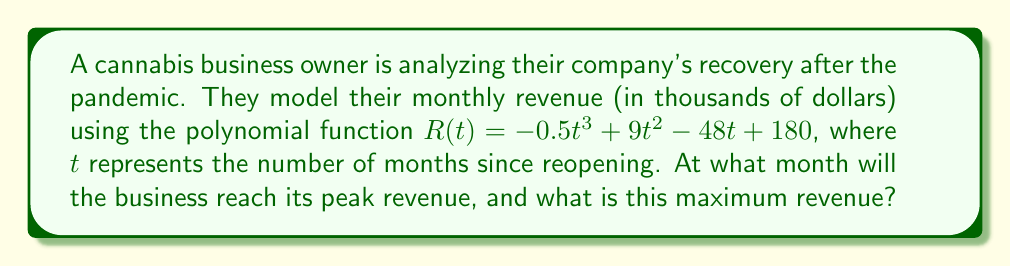Show me your answer to this math problem. To find the month of peak revenue and its value, we need to follow these steps:

1) The maximum point of the revenue function occurs where its derivative equals zero. Let's find the derivative of $R(t)$:

   $R'(t) = -1.5t^2 + 18t - 48$

2) Set $R'(t) = 0$ and solve for $t$:

   $-1.5t^2 + 18t - 48 = 0$

3) This is a quadratic equation. We can solve it using the quadratic formula:
   $t = \frac{-b \pm \sqrt{b^2 - 4ac}}{2a}$

   Where $a = -1.5$, $b = 18$, and $c = -48$

4) Substituting these values:

   $t = \frac{-18 \pm \sqrt{18^2 - 4(-1.5)(-48)}}{2(-1.5)}$

   $= \frac{-18 \pm \sqrt{324 - 288}}{-3}$

   $= \frac{-18 \pm \sqrt{36}}{-3}$

   $= \frac{-18 \pm 6}{-3}$

5) This gives us two solutions:
   $t = \frac{-18 + 6}{-3} = 4$ or $t = \frac{-18 - 6}{-3} = 8$

6) The second derivative $R''(t) = -3t + 18$ is negative when $t > 6$, so the maximum occurs at $t = 4$ months.

7) To find the maximum revenue, we substitute $t = 4$ into the original function:

   $R(4) = -0.5(4)^3 + 9(4)^2 - 48(4) + 180$
         $= -32 + 144 - 192 + 180$
         $= 100$

Therefore, the peak revenue of $100,000 will occur 4 months after reopening.
Answer: 4 months; $100,000 